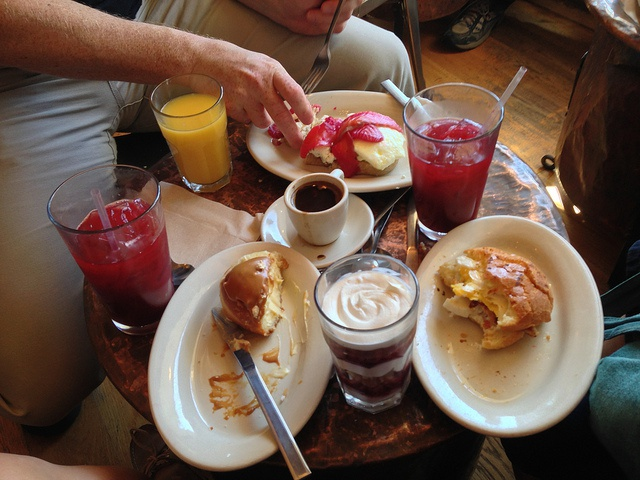Describe the objects in this image and their specific colors. I can see dining table in brown, black, darkgray, maroon, and tan tones, people in brown, maroon, gray, and black tones, cup in brown, maroon, black, and gray tones, cup in brown, lightgray, black, gray, and darkgray tones, and cup in brown, maroon, and black tones in this image. 